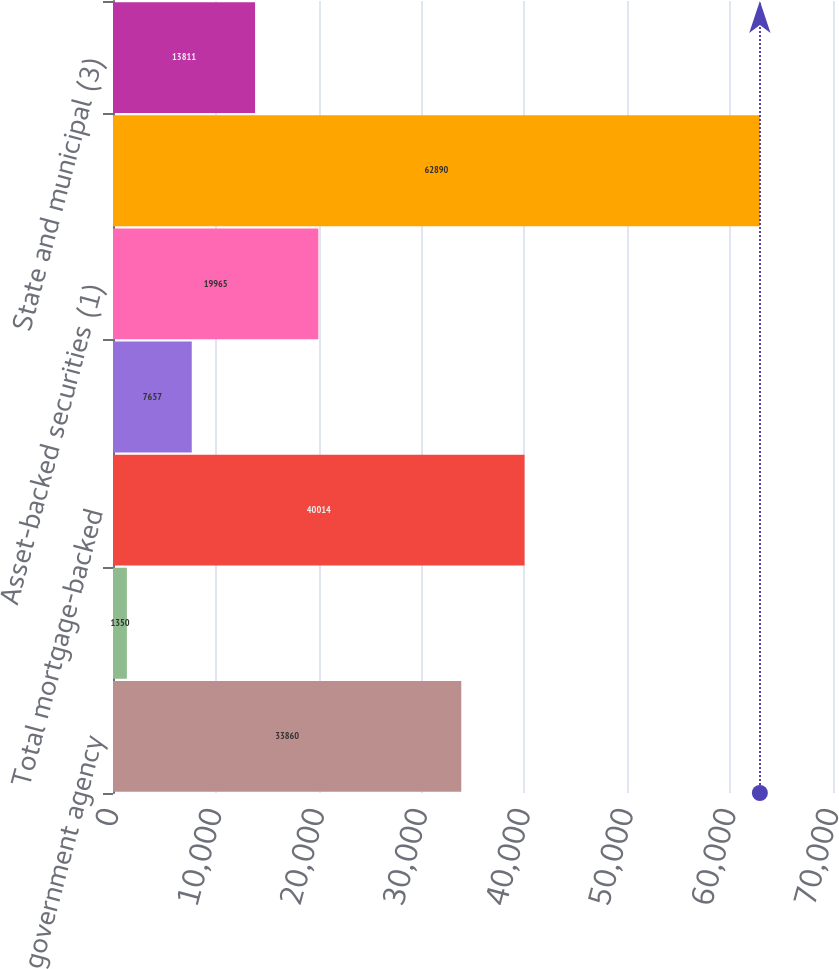Convert chart to OTSL. <chart><loc_0><loc_0><loc_500><loc_500><bar_chart><fcel>US government agency<fcel>Non-US residential<fcel>Total mortgage-backed<fcel>State and municipal<fcel>Asset-backed securities (1)<fcel>Total debt securities HTM<fcel>State and municipal (3)<nl><fcel>33860<fcel>1350<fcel>40014<fcel>7657<fcel>19965<fcel>62890<fcel>13811<nl></chart> 